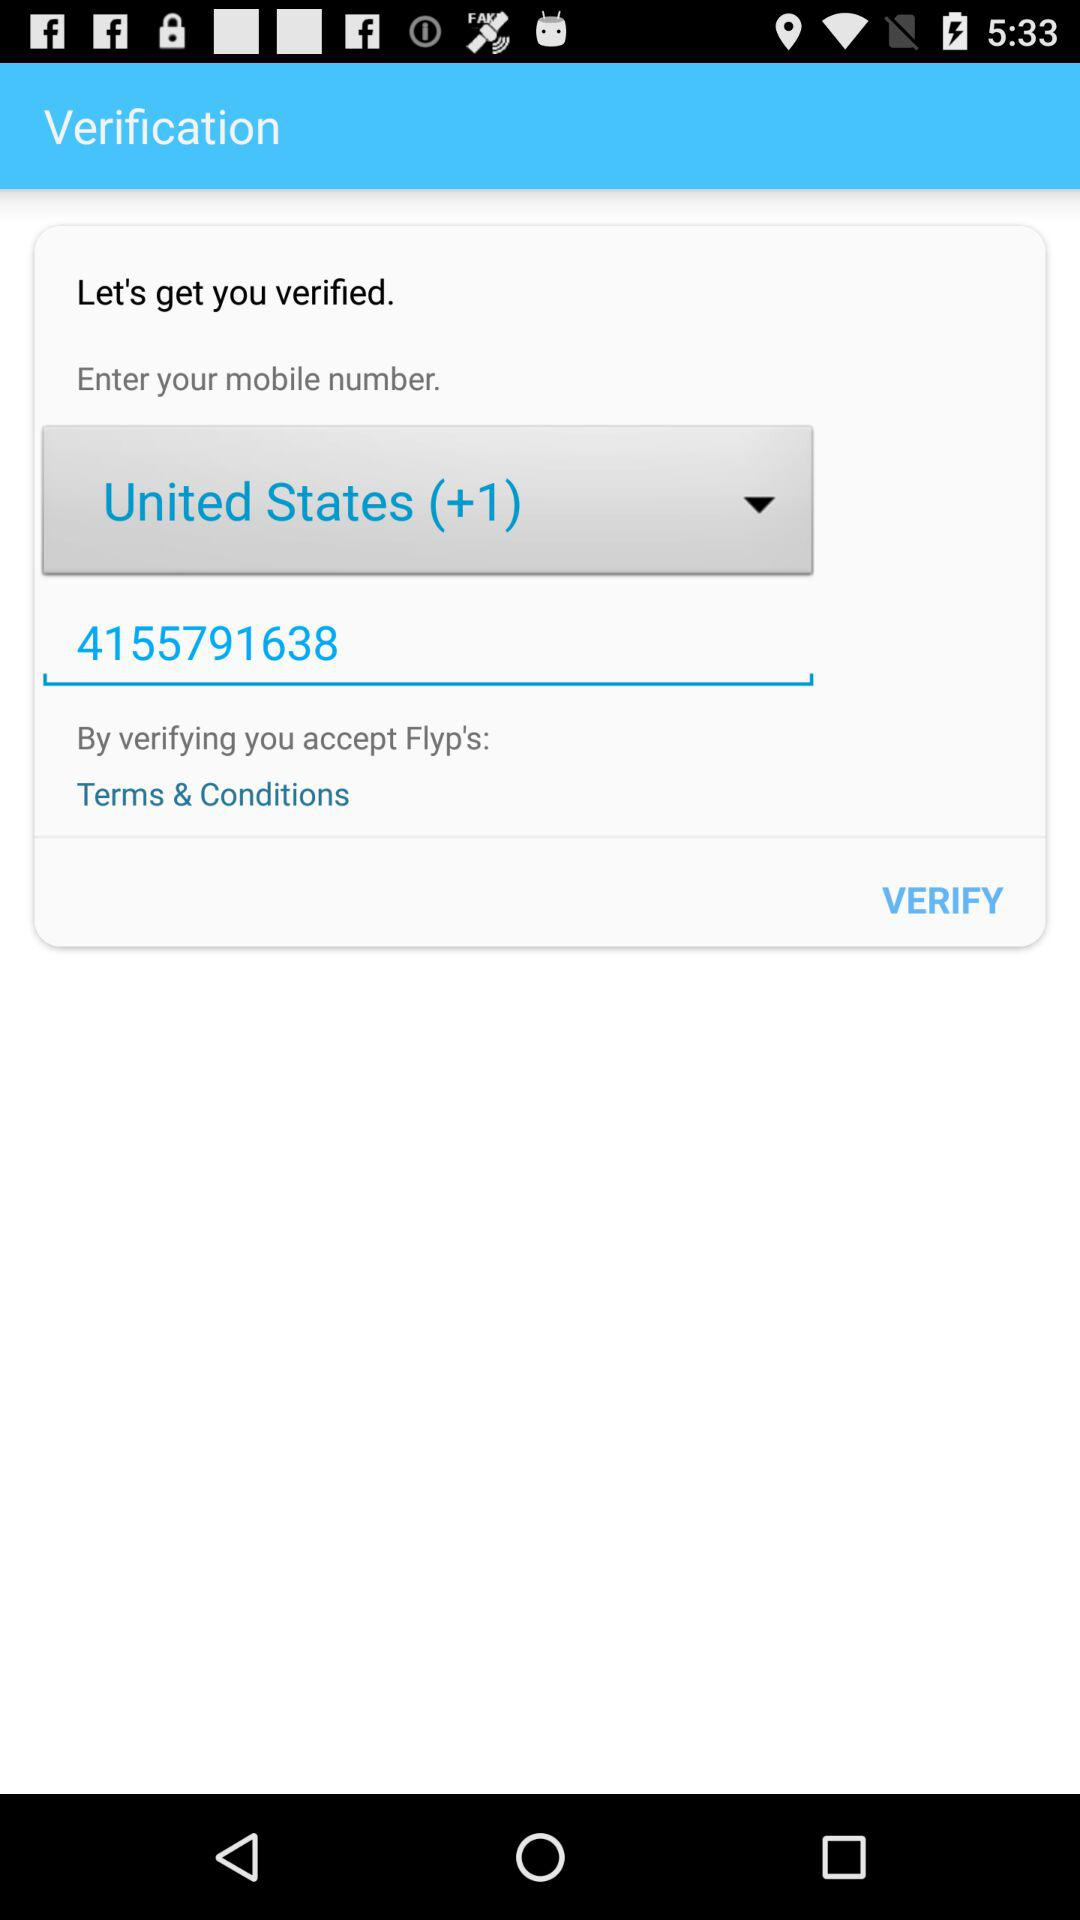What is the code for the United States? The code for the United States is +1. 